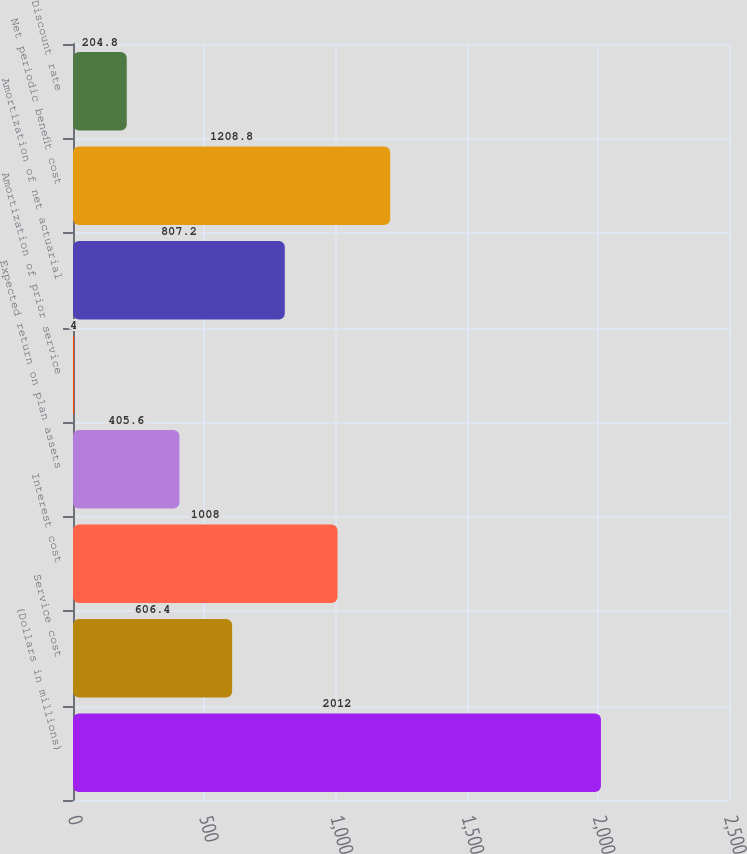<chart> <loc_0><loc_0><loc_500><loc_500><bar_chart><fcel>(Dollars in millions)<fcel>Service cost<fcel>Interest cost<fcel>Expected return on plan assets<fcel>Amortization of prior service<fcel>Amortization of net actuarial<fcel>Net periodic benefit cost<fcel>Discount rate<nl><fcel>2012<fcel>606.4<fcel>1008<fcel>405.6<fcel>4<fcel>807.2<fcel>1208.8<fcel>204.8<nl></chart> 